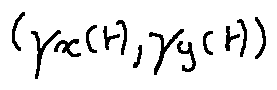Convert formula to latex. <formula><loc_0><loc_0><loc_500><loc_500>( \gamma _ { x } ( t ) , \gamma _ { y } ( t ) )</formula> 